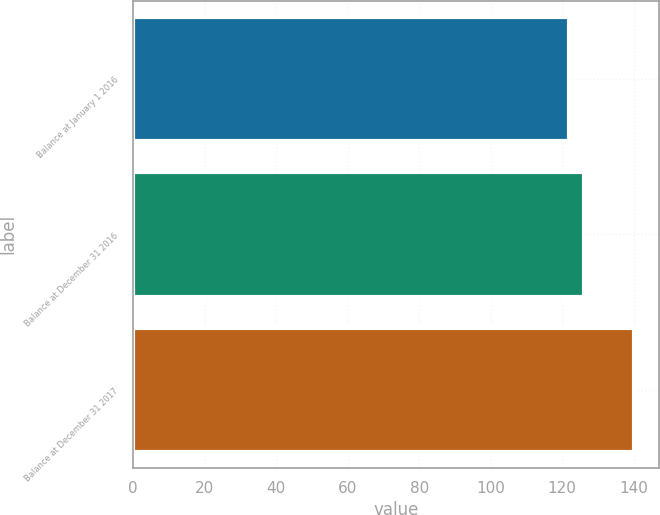Convert chart. <chart><loc_0><loc_0><loc_500><loc_500><bar_chart><fcel>Balance at January 1 2016<fcel>Balance at December 31 2016<fcel>Balance at December 31 2017<nl><fcel>122<fcel>126<fcel>140<nl></chart> 